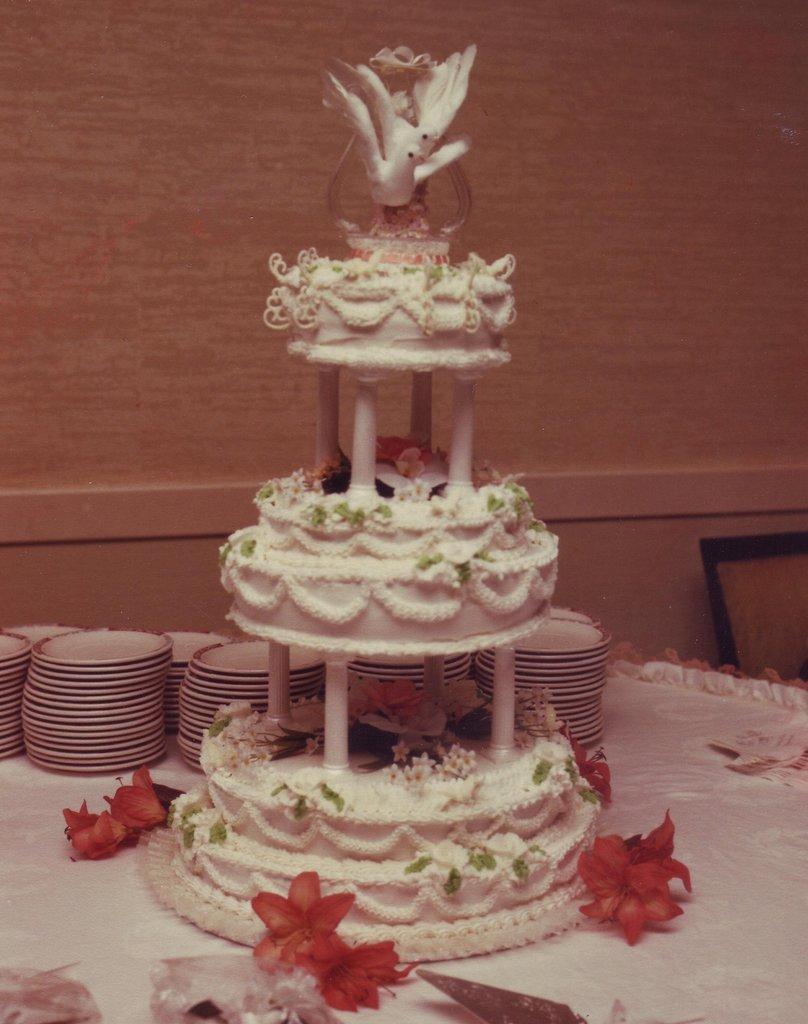How would you summarize this image in a sentence or two? In this image I can see a cake on a table and here I can see number of plates. 